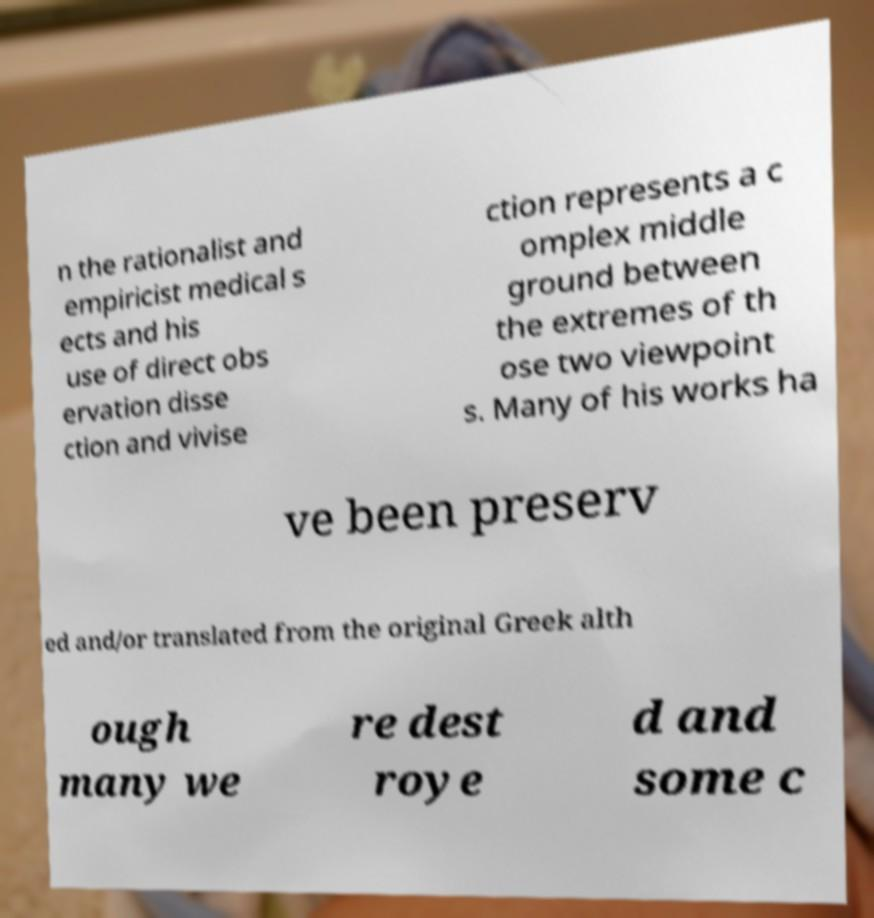Can you read and provide the text displayed in the image?This photo seems to have some interesting text. Can you extract and type it out for me? n the rationalist and empiricist medical s ects and his use of direct obs ervation disse ction and vivise ction represents a c omplex middle ground between the extremes of th ose two viewpoint s. Many of his works ha ve been preserv ed and/or translated from the original Greek alth ough many we re dest roye d and some c 